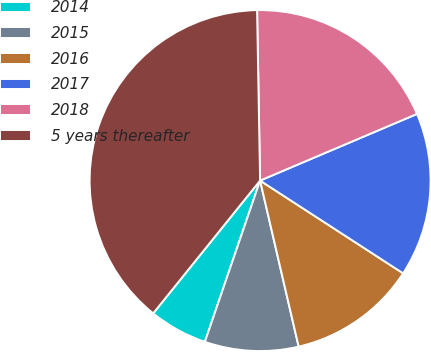<chart> <loc_0><loc_0><loc_500><loc_500><pie_chart><fcel>2014<fcel>2015<fcel>2016<fcel>2017<fcel>2018<fcel>5 years thereafter<nl><fcel>5.54%<fcel>8.88%<fcel>12.21%<fcel>15.55%<fcel>18.89%<fcel>38.93%<nl></chart> 